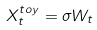Convert formula to latex. <formula><loc_0><loc_0><loc_500><loc_500>X _ { t } ^ { t o y } = \sigma W _ { t }</formula> 